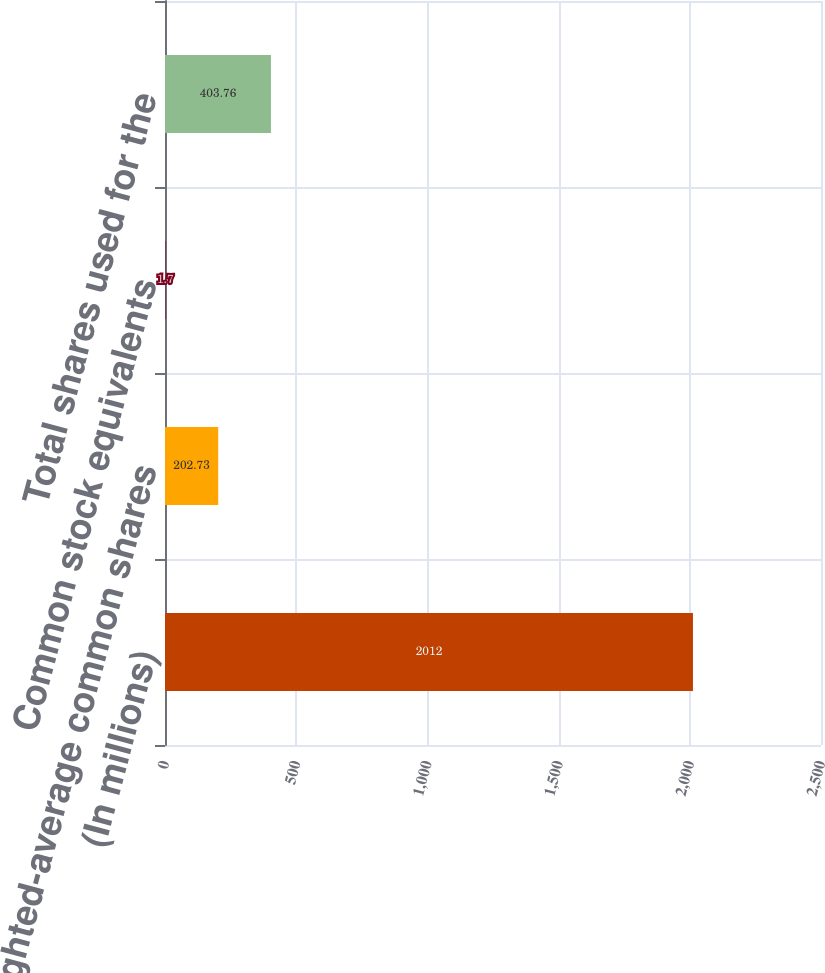<chart> <loc_0><loc_0><loc_500><loc_500><bar_chart><fcel>(In millions)<fcel>Weighted-average common shares<fcel>Common stock equivalents<fcel>Total shares used for the<nl><fcel>2012<fcel>202.73<fcel>1.7<fcel>403.76<nl></chart> 